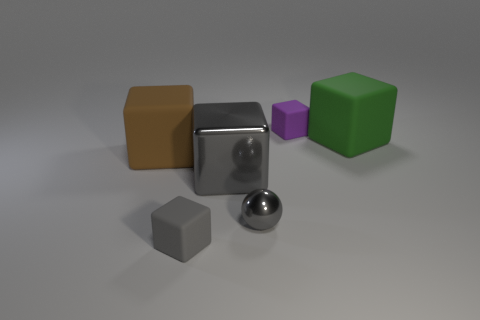Subtract all green matte blocks. How many blocks are left? 4 Add 1 small yellow metal objects. How many objects exist? 7 Subtract 4 blocks. How many blocks are left? 1 Subtract all green blocks. How many blocks are left? 4 Subtract all large green matte things. Subtract all purple matte things. How many objects are left? 4 Add 4 cubes. How many cubes are left? 9 Add 4 tiny purple cubes. How many tiny purple cubes exist? 5 Subtract 0 purple balls. How many objects are left? 6 Subtract all spheres. How many objects are left? 5 Subtract all green blocks. Subtract all blue cylinders. How many blocks are left? 4 